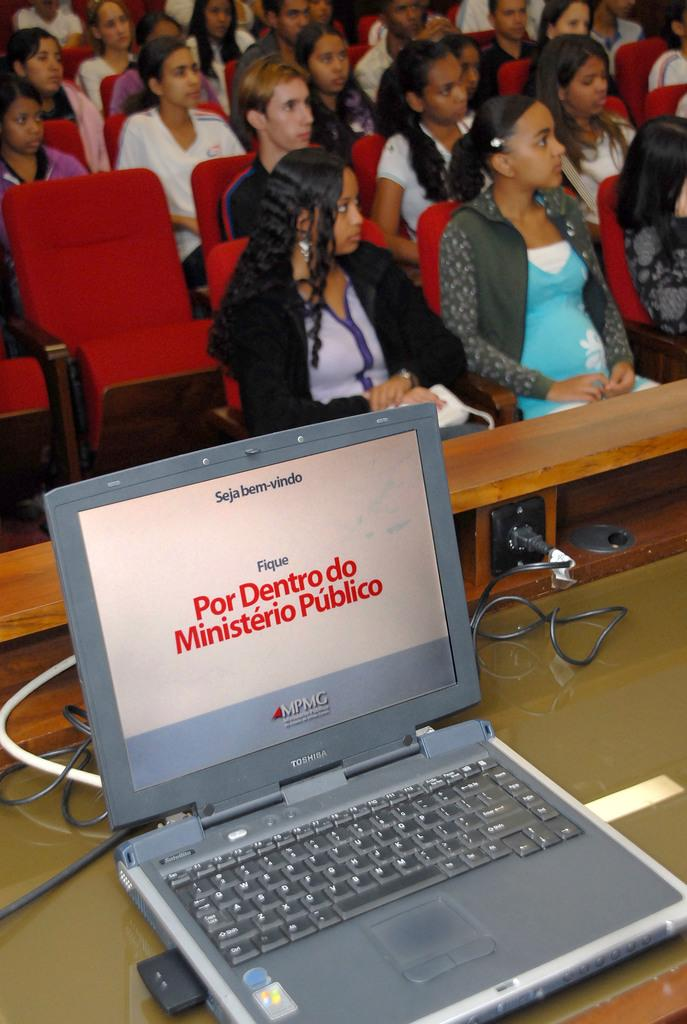What type of venue is depicted in the image? The image appears to be an auditorium. What color are the chairs in the auditorium? The chairs in the auditorium are red. How many people are seated in the auditorium? Many people are seated on the chairs. What electronic devices can be seen in the image? There is a laptop and a screen in the image. What other items related to electricity can be seen in the image? There are wires and a switch board in the image. What type of furniture is present in the image? There is a table in the image. Can you observe any hands in the image? There is no specific mention of hands in the image, so it cannot be determined if any are present. 